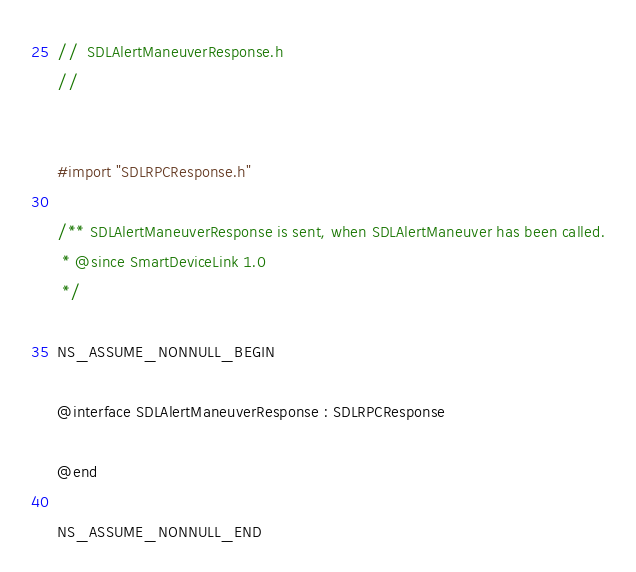<code> <loc_0><loc_0><loc_500><loc_500><_C_>//  SDLAlertManeuverResponse.h
//


#import "SDLRPCResponse.h"

/** SDLAlertManeuverResponse is sent, when SDLAlertManeuver has been called.
 * @since SmartDeviceLink 1.0
 */

NS_ASSUME_NONNULL_BEGIN

@interface SDLAlertManeuverResponse : SDLRPCResponse

@end

NS_ASSUME_NONNULL_END
</code> 